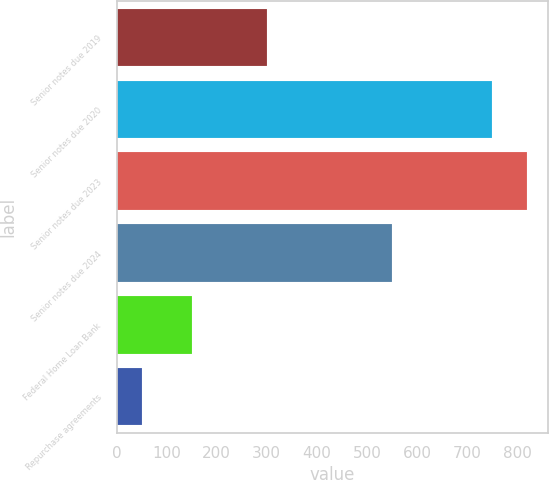Convert chart. <chart><loc_0><loc_0><loc_500><loc_500><bar_chart><fcel>Senior notes due 2019<fcel>Senior notes due 2020<fcel>Senior notes due 2023<fcel>Senior notes due 2024<fcel>Federal Home Loan Bank<fcel>Repurchase agreements<nl><fcel>300<fcel>750<fcel>820<fcel>550<fcel>150<fcel>50<nl></chart> 